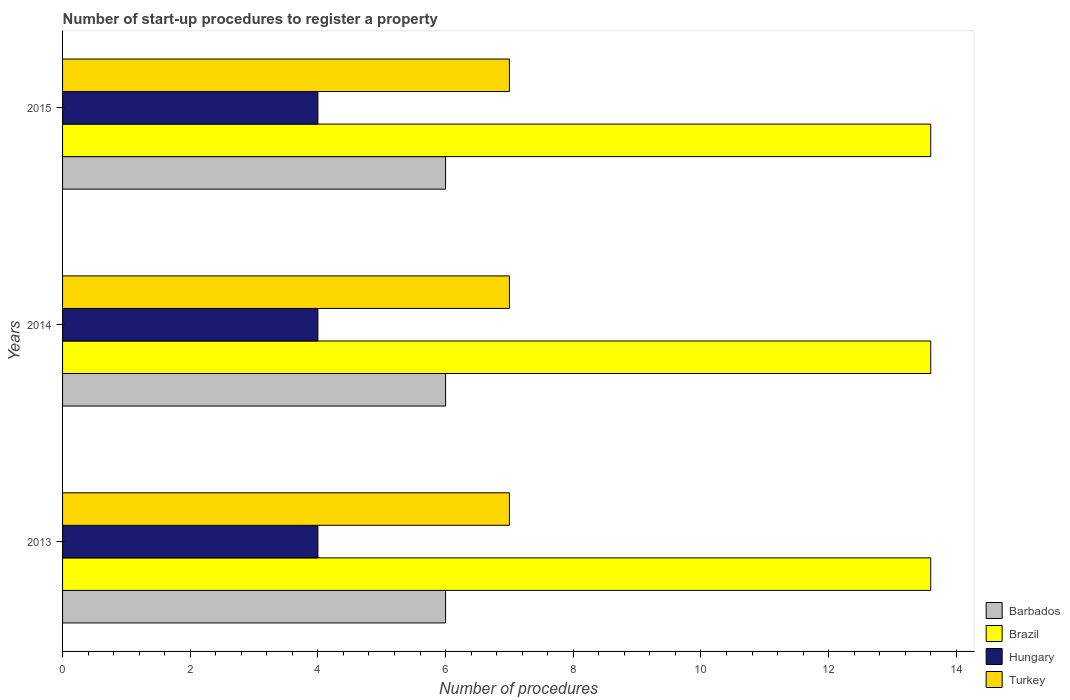Are the number of bars per tick equal to the number of legend labels?
Ensure brevity in your answer.  Yes. Are the number of bars on each tick of the Y-axis equal?
Give a very brief answer. Yes. How many bars are there on the 2nd tick from the top?
Your response must be concise. 4. How many bars are there on the 1st tick from the bottom?
Provide a succinct answer. 4. In how many cases, is the number of bars for a given year not equal to the number of legend labels?
Offer a terse response. 0. What is the number of procedures required to register a property in Hungary in 2013?
Keep it short and to the point. 4. Across all years, what is the maximum number of procedures required to register a property in Hungary?
Keep it short and to the point. 4. In which year was the number of procedures required to register a property in Turkey minimum?
Your answer should be compact. 2013. What is the total number of procedures required to register a property in Brazil in the graph?
Provide a succinct answer. 40.8. What is the difference between the number of procedures required to register a property in Turkey in 2013 and the number of procedures required to register a property in Hungary in 2015?
Provide a short and direct response. 3. What is the average number of procedures required to register a property in Turkey per year?
Your response must be concise. 7. In how many years, is the number of procedures required to register a property in Barbados greater than 13.2 ?
Offer a very short reply. 0. What is the ratio of the number of procedures required to register a property in Brazil in 2014 to that in 2015?
Your answer should be compact. 1. Is the number of procedures required to register a property in Turkey in 2013 less than that in 2014?
Give a very brief answer. No. What is the difference between the highest and the lowest number of procedures required to register a property in Hungary?
Make the answer very short. 0. What does the 1st bar from the top in 2014 represents?
Provide a short and direct response. Turkey. Is it the case that in every year, the sum of the number of procedures required to register a property in Brazil and number of procedures required to register a property in Turkey is greater than the number of procedures required to register a property in Hungary?
Provide a short and direct response. Yes. How many bars are there?
Provide a short and direct response. 12. Are the values on the major ticks of X-axis written in scientific E-notation?
Provide a succinct answer. No. What is the title of the graph?
Your answer should be very brief. Number of start-up procedures to register a property. Does "Libya" appear as one of the legend labels in the graph?
Make the answer very short. No. What is the label or title of the X-axis?
Your answer should be very brief. Number of procedures. What is the Number of procedures in Barbados in 2013?
Your response must be concise. 6. What is the Number of procedures in Brazil in 2013?
Make the answer very short. 13.6. What is the Number of procedures in Hungary in 2013?
Offer a terse response. 4. What is the Number of procedures of Turkey in 2013?
Make the answer very short. 7. What is the Number of procedures of Barbados in 2014?
Offer a very short reply. 6. What is the Number of procedures of Hungary in 2014?
Your answer should be very brief. 4. What is the Number of procedures in Turkey in 2014?
Make the answer very short. 7. What is the Number of procedures in Barbados in 2015?
Give a very brief answer. 6. What is the Number of procedures in Turkey in 2015?
Your response must be concise. 7. Across all years, what is the maximum Number of procedures in Turkey?
Your answer should be compact. 7. Across all years, what is the minimum Number of procedures in Brazil?
Keep it short and to the point. 13.6. What is the total Number of procedures in Brazil in the graph?
Give a very brief answer. 40.8. What is the difference between the Number of procedures in Hungary in 2013 and that in 2014?
Your response must be concise. 0. What is the difference between the Number of procedures of Turkey in 2013 and that in 2014?
Offer a very short reply. 0. What is the difference between the Number of procedures in Brazil in 2013 and that in 2015?
Provide a short and direct response. 0. What is the difference between the Number of procedures in Turkey in 2013 and that in 2015?
Ensure brevity in your answer.  0. What is the difference between the Number of procedures of Barbados in 2014 and that in 2015?
Keep it short and to the point. 0. What is the difference between the Number of procedures of Brazil in 2014 and that in 2015?
Offer a terse response. 0. What is the difference between the Number of procedures of Barbados in 2013 and the Number of procedures of Brazil in 2014?
Ensure brevity in your answer.  -7.6. What is the difference between the Number of procedures in Barbados in 2013 and the Number of procedures in Hungary in 2014?
Provide a succinct answer. 2. What is the difference between the Number of procedures in Hungary in 2013 and the Number of procedures in Turkey in 2014?
Your answer should be very brief. -3. What is the difference between the Number of procedures in Barbados in 2013 and the Number of procedures in Turkey in 2015?
Keep it short and to the point. -1. What is the difference between the Number of procedures in Brazil in 2013 and the Number of procedures in Turkey in 2015?
Your answer should be very brief. 6.6. What is the difference between the Number of procedures in Barbados in 2014 and the Number of procedures in Turkey in 2015?
Make the answer very short. -1. What is the difference between the Number of procedures of Hungary in 2014 and the Number of procedures of Turkey in 2015?
Your answer should be compact. -3. What is the average Number of procedures in Barbados per year?
Make the answer very short. 6. What is the average Number of procedures in Brazil per year?
Your response must be concise. 13.6. What is the average Number of procedures of Turkey per year?
Offer a terse response. 7. In the year 2013, what is the difference between the Number of procedures of Barbados and Number of procedures of Brazil?
Offer a terse response. -7.6. In the year 2013, what is the difference between the Number of procedures in Barbados and Number of procedures in Hungary?
Ensure brevity in your answer.  2. In the year 2013, what is the difference between the Number of procedures in Brazil and Number of procedures in Turkey?
Your answer should be compact. 6.6. In the year 2013, what is the difference between the Number of procedures of Hungary and Number of procedures of Turkey?
Provide a short and direct response. -3. In the year 2014, what is the difference between the Number of procedures of Barbados and Number of procedures of Brazil?
Make the answer very short. -7.6. In the year 2014, what is the difference between the Number of procedures of Barbados and Number of procedures of Hungary?
Your response must be concise. 2. In the year 2014, what is the difference between the Number of procedures in Barbados and Number of procedures in Turkey?
Offer a terse response. -1. In the year 2015, what is the difference between the Number of procedures in Barbados and Number of procedures in Hungary?
Make the answer very short. 2. In the year 2015, what is the difference between the Number of procedures in Brazil and Number of procedures in Hungary?
Offer a terse response. 9.6. In the year 2015, what is the difference between the Number of procedures in Hungary and Number of procedures in Turkey?
Make the answer very short. -3. What is the ratio of the Number of procedures of Barbados in 2013 to that in 2014?
Your answer should be very brief. 1. What is the ratio of the Number of procedures in Brazil in 2013 to that in 2014?
Your answer should be compact. 1. What is the ratio of the Number of procedures in Brazil in 2013 to that in 2015?
Provide a short and direct response. 1. What is the ratio of the Number of procedures of Hungary in 2013 to that in 2015?
Your answer should be compact. 1. What is the ratio of the Number of procedures of Turkey in 2013 to that in 2015?
Provide a succinct answer. 1. What is the ratio of the Number of procedures in Barbados in 2014 to that in 2015?
Keep it short and to the point. 1. What is the ratio of the Number of procedures of Brazil in 2014 to that in 2015?
Give a very brief answer. 1. What is the ratio of the Number of procedures in Hungary in 2014 to that in 2015?
Provide a succinct answer. 1. What is the difference between the highest and the second highest Number of procedures of Hungary?
Provide a short and direct response. 0. What is the difference between the highest and the second highest Number of procedures in Turkey?
Offer a very short reply. 0. What is the difference between the highest and the lowest Number of procedures in Brazil?
Keep it short and to the point. 0. What is the difference between the highest and the lowest Number of procedures of Hungary?
Provide a short and direct response. 0. What is the difference between the highest and the lowest Number of procedures of Turkey?
Your response must be concise. 0. 